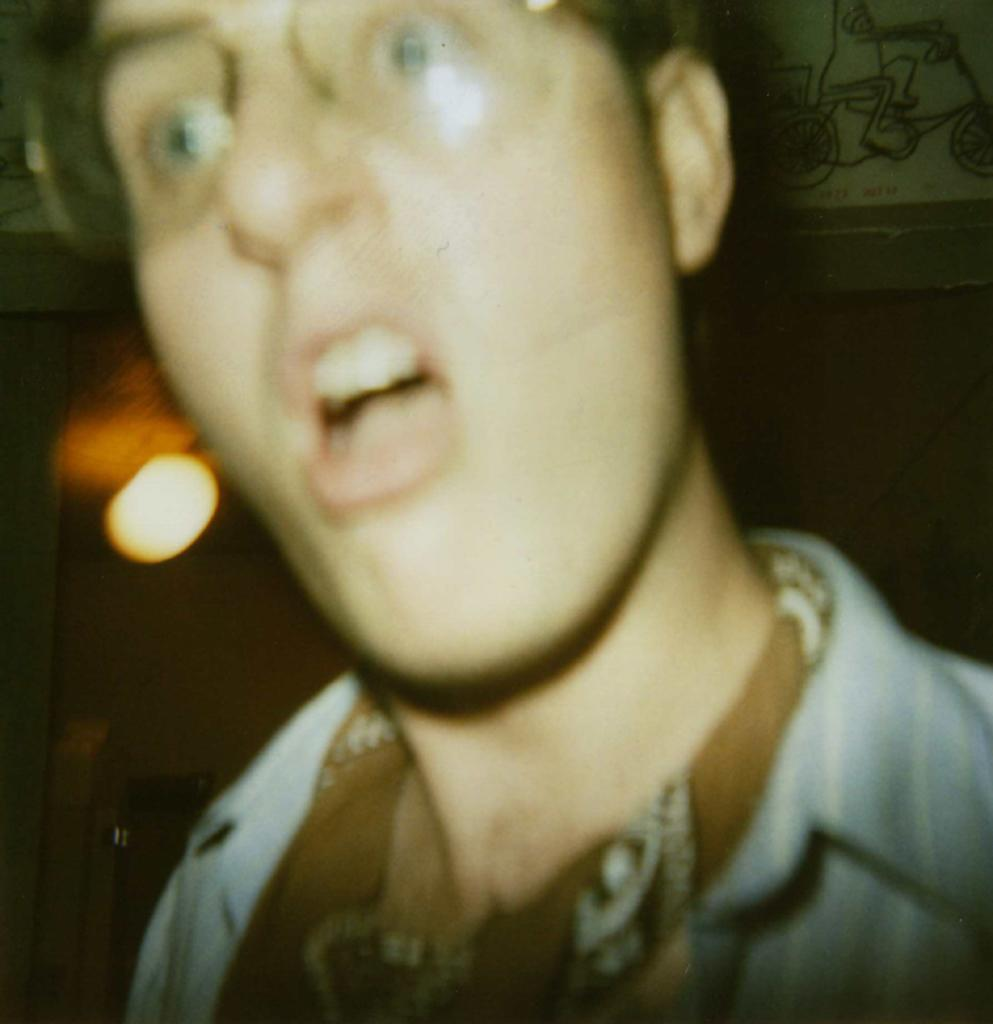What is the main subject of the image? There is a person standing in the image. Where is the person located in the image? The person is on the left side of the image. What can be seen on the left side of the image besides the person? There is a light visible on the left side of the image. What type of structure is visible in the image? There is a wall visible in the image. What type of insurance policy does the person have in the image? There is no information about insurance policies in the image; it only shows a person standing near a light and a wall. 